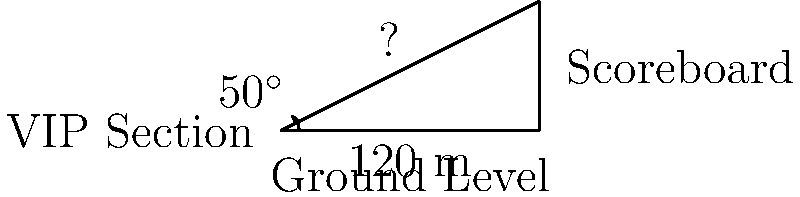As the owner of a state-of-the-art stadium, you've installed a massive scoreboard to enhance the viewing experience. The VIP section is located 120 meters away from the base of the scoreboard. If the angle of elevation from the VIP section to the top of the scoreboard is 50°, what is the height of the scoreboard? Round your answer to the nearest meter. Let's approach this step-by-step using trigonometry:

1) We can represent this scenario as a right-angled triangle where:
   - The base of the triangle is the distance from the VIP section to the scoreboard (120 m)
   - The height of the triangle is the height of the scoreboard (what we're solving for)
   - The angle of elevation is 50°

2) In this right-angled triangle, we know:
   - The adjacent side (base) = 120 m
   - The angle = 50°
   - We need to find the opposite side (height)

3) The trigonometric ratio that relates the opposite side to the adjacent side is the tangent (tan):

   $$\tan \theta = \frac{\text{opposite}}{\text{adjacent}}$$

4) Substituting our known values:

   $$\tan 50° = \frac{\text{height}}{120}$$

5) To solve for the height, we multiply both sides by 120:

   $$120 \cdot \tan 50° = \text{height}$$

6) Using a calculator (or trigonometric tables):

   $$120 \cdot \tan 50° \approx 120 \cdot 1.1918 \approx 143.016$$

7) Rounding to the nearest meter:

   Height ≈ 143 m

Therefore, the height of the scoreboard is approximately 143 meters.
Answer: 143 m 